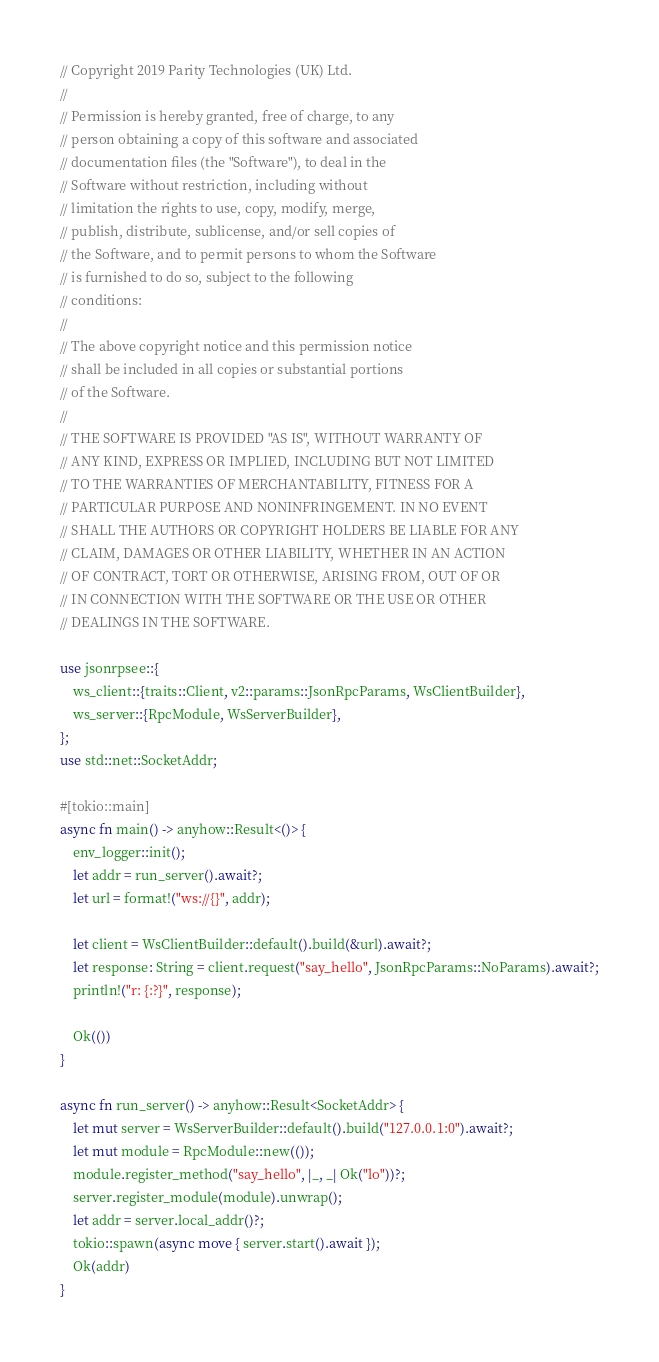Convert code to text. <code><loc_0><loc_0><loc_500><loc_500><_Rust_>// Copyright 2019 Parity Technologies (UK) Ltd.
//
// Permission is hereby granted, free of charge, to any
// person obtaining a copy of this software and associated
// documentation files (the "Software"), to deal in the
// Software without restriction, including without
// limitation the rights to use, copy, modify, merge,
// publish, distribute, sublicense, and/or sell copies of
// the Software, and to permit persons to whom the Software
// is furnished to do so, subject to the following
// conditions:
//
// The above copyright notice and this permission notice
// shall be included in all copies or substantial portions
// of the Software.
//
// THE SOFTWARE IS PROVIDED "AS IS", WITHOUT WARRANTY OF
// ANY KIND, EXPRESS OR IMPLIED, INCLUDING BUT NOT LIMITED
// TO THE WARRANTIES OF MERCHANTABILITY, FITNESS FOR A
// PARTICULAR PURPOSE AND NONINFRINGEMENT. IN NO EVENT
// SHALL THE AUTHORS OR COPYRIGHT HOLDERS BE LIABLE FOR ANY
// CLAIM, DAMAGES OR OTHER LIABILITY, WHETHER IN AN ACTION
// OF CONTRACT, TORT OR OTHERWISE, ARISING FROM, OUT OF OR
// IN CONNECTION WITH THE SOFTWARE OR THE USE OR OTHER
// DEALINGS IN THE SOFTWARE.

use jsonrpsee::{
	ws_client::{traits::Client, v2::params::JsonRpcParams, WsClientBuilder},
	ws_server::{RpcModule, WsServerBuilder},
};
use std::net::SocketAddr;

#[tokio::main]
async fn main() -> anyhow::Result<()> {
	env_logger::init();
	let addr = run_server().await?;
	let url = format!("ws://{}", addr);

	let client = WsClientBuilder::default().build(&url).await?;
	let response: String = client.request("say_hello", JsonRpcParams::NoParams).await?;
	println!("r: {:?}", response);

	Ok(())
}

async fn run_server() -> anyhow::Result<SocketAddr> {
	let mut server = WsServerBuilder::default().build("127.0.0.1:0").await?;
	let mut module = RpcModule::new(());
	module.register_method("say_hello", |_, _| Ok("lo"))?;
	server.register_module(module).unwrap();
	let addr = server.local_addr()?;
	tokio::spawn(async move { server.start().await });
	Ok(addr)
}
</code> 